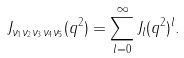<formula> <loc_0><loc_0><loc_500><loc_500>J _ { \nu _ { 1 } \nu _ { 2 } \nu _ { 3 } \nu _ { 4 } \nu _ { 5 } } ( q ^ { 2 } ) = \sum _ { l = 0 } ^ { \infty } J _ { l } ( q ^ { 2 } ) ^ { l } .</formula> 